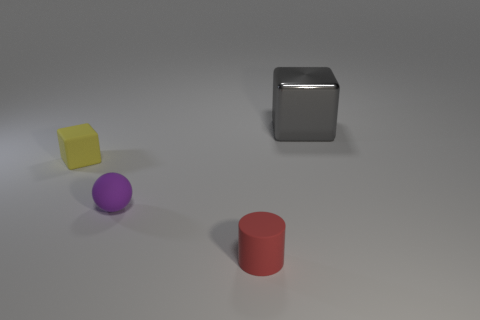What number of things are either small rubber spheres or yellow rubber blocks?
Offer a very short reply. 2. Are any red rubber objects visible?
Give a very brief answer. Yes. There is a cube that is behind the block left of the small rubber thing in front of the rubber ball; what is its material?
Ensure brevity in your answer.  Metal. Is the number of metal cubes that are in front of the cylinder less than the number of matte balls?
Make the answer very short. Yes. There is a red cylinder that is the same size as the matte ball; what is it made of?
Provide a short and direct response. Rubber. There is a matte object that is both behind the small cylinder and on the right side of the tiny matte cube; what size is it?
Your response must be concise. Small. There is a yellow matte thing that is the same shape as the big metal thing; what size is it?
Your answer should be compact. Small. What number of objects are either tiny spheres or things behind the red rubber cylinder?
Give a very brief answer. 3. What is the shape of the big gray thing?
Offer a very short reply. Cube. The thing behind the block on the left side of the small red matte thing is what shape?
Offer a very short reply. Cube. 